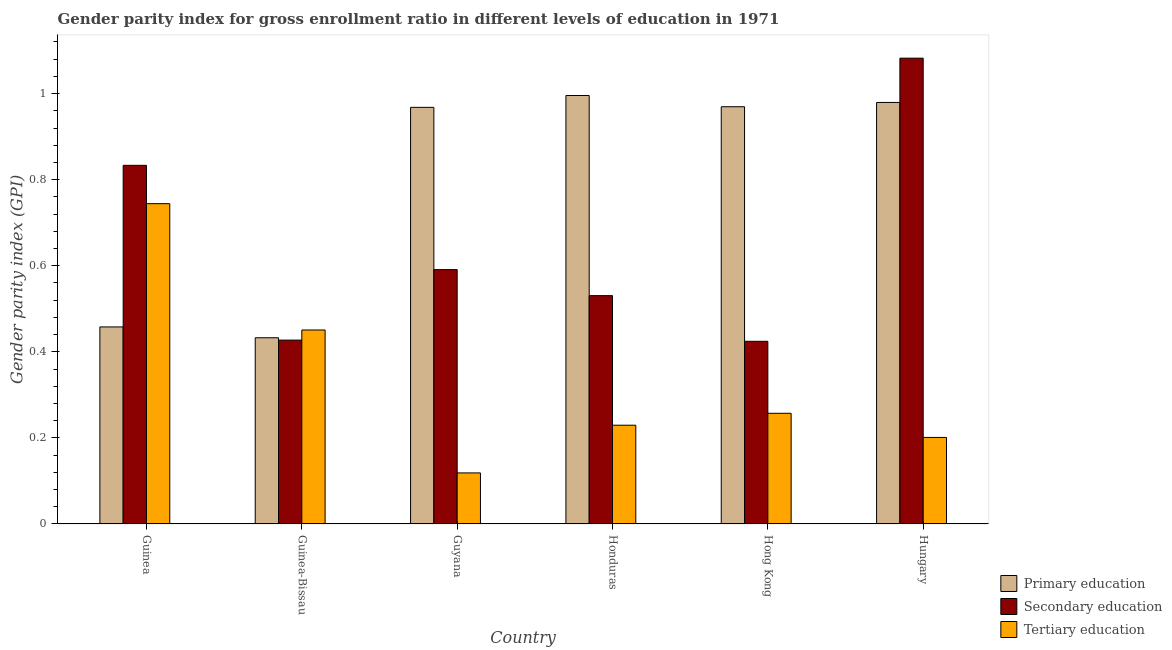Are the number of bars per tick equal to the number of legend labels?
Your answer should be very brief. Yes. How many bars are there on the 3rd tick from the left?
Your answer should be compact. 3. How many bars are there on the 5th tick from the right?
Make the answer very short. 3. What is the label of the 6th group of bars from the left?
Provide a succinct answer. Hungary. What is the gender parity index in secondary education in Guinea?
Your answer should be compact. 0.83. Across all countries, what is the maximum gender parity index in tertiary education?
Provide a short and direct response. 0.74. Across all countries, what is the minimum gender parity index in secondary education?
Your answer should be very brief. 0.42. In which country was the gender parity index in tertiary education maximum?
Offer a terse response. Guinea. In which country was the gender parity index in tertiary education minimum?
Make the answer very short. Guyana. What is the total gender parity index in primary education in the graph?
Ensure brevity in your answer.  4.8. What is the difference between the gender parity index in primary education in Guyana and that in Hungary?
Give a very brief answer. -0.01. What is the difference between the gender parity index in tertiary education in Guyana and the gender parity index in primary education in Honduras?
Keep it short and to the point. -0.88. What is the average gender parity index in tertiary education per country?
Your response must be concise. 0.33. What is the difference between the gender parity index in tertiary education and gender parity index in primary education in Hungary?
Offer a terse response. -0.78. In how many countries, is the gender parity index in secondary education greater than 0.9600000000000001 ?
Your answer should be very brief. 1. What is the ratio of the gender parity index in primary education in Honduras to that in Hong Kong?
Offer a very short reply. 1.03. Is the gender parity index in primary education in Guyana less than that in Hungary?
Offer a very short reply. Yes. What is the difference between the highest and the second highest gender parity index in tertiary education?
Provide a short and direct response. 0.29. What is the difference between the highest and the lowest gender parity index in primary education?
Offer a terse response. 0.56. In how many countries, is the gender parity index in primary education greater than the average gender parity index in primary education taken over all countries?
Your answer should be compact. 4. Is the sum of the gender parity index in tertiary education in Guyana and Hong Kong greater than the maximum gender parity index in primary education across all countries?
Give a very brief answer. No. What does the 2nd bar from the left in Hong Kong represents?
Your answer should be very brief. Secondary education. How many countries are there in the graph?
Your answer should be very brief. 6. Does the graph contain grids?
Ensure brevity in your answer.  No. Where does the legend appear in the graph?
Make the answer very short. Bottom right. What is the title of the graph?
Offer a terse response. Gender parity index for gross enrollment ratio in different levels of education in 1971. Does "Maunufacturing" appear as one of the legend labels in the graph?
Offer a terse response. No. What is the label or title of the X-axis?
Your answer should be very brief. Country. What is the label or title of the Y-axis?
Keep it short and to the point. Gender parity index (GPI). What is the Gender parity index (GPI) in Primary education in Guinea?
Make the answer very short. 0.46. What is the Gender parity index (GPI) of Tertiary education in Guinea?
Give a very brief answer. 0.74. What is the Gender parity index (GPI) of Primary education in Guinea-Bissau?
Your answer should be very brief. 0.43. What is the Gender parity index (GPI) of Secondary education in Guinea-Bissau?
Keep it short and to the point. 0.43. What is the Gender parity index (GPI) of Tertiary education in Guinea-Bissau?
Offer a terse response. 0.45. What is the Gender parity index (GPI) of Primary education in Guyana?
Offer a terse response. 0.97. What is the Gender parity index (GPI) of Secondary education in Guyana?
Keep it short and to the point. 0.59. What is the Gender parity index (GPI) of Tertiary education in Guyana?
Give a very brief answer. 0.12. What is the Gender parity index (GPI) of Primary education in Honduras?
Your response must be concise. 1. What is the Gender parity index (GPI) of Secondary education in Honduras?
Provide a succinct answer. 0.53. What is the Gender parity index (GPI) of Tertiary education in Honduras?
Offer a very short reply. 0.23. What is the Gender parity index (GPI) of Primary education in Hong Kong?
Your answer should be very brief. 0.97. What is the Gender parity index (GPI) of Secondary education in Hong Kong?
Your answer should be very brief. 0.42. What is the Gender parity index (GPI) of Tertiary education in Hong Kong?
Provide a succinct answer. 0.26. What is the Gender parity index (GPI) of Primary education in Hungary?
Your response must be concise. 0.98. What is the Gender parity index (GPI) of Secondary education in Hungary?
Keep it short and to the point. 1.08. What is the Gender parity index (GPI) in Tertiary education in Hungary?
Your response must be concise. 0.2. Across all countries, what is the maximum Gender parity index (GPI) in Primary education?
Your answer should be very brief. 1. Across all countries, what is the maximum Gender parity index (GPI) in Secondary education?
Your answer should be compact. 1.08. Across all countries, what is the maximum Gender parity index (GPI) of Tertiary education?
Make the answer very short. 0.74. Across all countries, what is the minimum Gender parity index (GPI) in Primary education?
Offer a very short reply. 0.43. Across all countries, what is the minimum Gender parity index (GPI) in Secondary education?
Provide a short and direct response. 0.42. Across all countries, what is the minimum Gender parity index (GPI) of Tertiary education?
Keep it short and to the point. 0.12. What is the total Gender parity index (GPI) of Primary education in the graph?
Keep it short and to the point. 4.8. What is the total Gender parity index (GPI) in Secondary education in the graph?
Your answer should be compact. 3.89. What is the total Gender parity index (GPI) in Tertiary education in the graph?
Your answer should be compact. 2. What is the difference between the Gender parity index (GPI) of Primary education in Guinea and that in Guinea-Bissau?
Offer a terse response. 0.03. What is the difference between the Gender parity index (GPI) in Secondary education in Guinea and that in Guinea-Bissau?
Your answer should be very brief. 0.41. What is the difference between the Gender parity index (GPI) of Tertiary education in Guinea and that in Guinea-Bissau?
Make the answer very short. 0.29. What is the difference between the Gender parity index (GPI) of Primary education in Guinea and that in Guyana?
Provide a succinct answer. -0.51. What is the difference between the Gender parity index (GPI) in Secondary education in Guinea and that in Guyana?
Give a very brief answer. 0.24. What is the difference between the Gender parity index (GPI) of Tertiary education in Guinea and that in Guyana?
Your answer should be very brief. 0.63. What is the difference between the Gender parity index (GPI) in Primary education in Guinea and that in Honduras?
Offer a very short reply. -0.54. What is the difference between the Gender parity index (GPI) in Secondary education in Guinea and that in Honduras?
Your answer should be compact. 0.3. What is the difference between the Gender parity index (GPI) of Tertiary education in Guinea and that in Honduras?
Ensure brevity in your answer.  0.51. What is the difference between the Gender parity index (GPI) of Primary education in Guinea and that in Hong Kong?
Give a very brief answer. -0.51. What is the difference between the Gender parity index (GPI) in Secondary education in Guinea and that in Hong Kong?
Your answer should be very brief. 0.41. What is the difference between the Gender parity index (GPI) of Tertiary education in Guinea and that in Hong Kong?
Your answer should be compact. 0.49. What is the difference between the Gender parity index (GPI) in Primary education in Guinea and that in Hungary?
Keep it short and to the point. -0.52. What is the difference between the Gender parity index (GPI) of Secondary education in Guinea and that in Hungary?
Your answer should be very brief. -0.25. What is the difference between the Gender parity index (GPI) of Tertiary education in Guinea and that in Hungary?
Offer a terse response. 0.54. What is the difference between the Gender parity index (GPI) in Primary education in Guinea-Bissau and that in Guyana?
Keep it short and to the point. -0.54. What is the difference between the Gender parity index (GPI) of Secondary education in Guinea-Bissau and that in Guyana?
Ensure brevity in your answer.  -0.16. What is the difference between the Gender parity index (GPI) in Tertiary education in Guinea-Bissau and that in Guyana?
Give a very brief answer. 0.33. What is the difference between the Gender parity index (GPI) of Primary education in Guinea-Bissau and that in Honduras?
Provide a succinct answer. -0.56. What is the difference between the Gender parity index (GPI) of Secondary education in Guinea-Bissau and that in Honduras?
Your answer should be very brief. -0.1. What is the difference between the Gender parity index (GPI) in Tertiary education in Guinea-Bissau and that in Honduras?
Your response must be concise. 0.22. What is the difference between the Gender parity index (GPI) of Primary education in Guinea-Bissau and that in Hong Kong?
Ensure brevity in your answer.  -0.54. What is the difference between the Gender parity index (GPI) of Secondary education in Guinea-Bissau and that in Hong Kong?
Offer a very short reply. 0. What is the difference between the Gender parity index (GPI) of Tertiary education in Guinea-Bissau and that in Hong Kong?
Give a very brief answer. 0.19. What is the difference between the Gender parity index (GPI) in Primary education in Guinea-Bissau and that in Hungary?
Offer a very short reply. -0.55. What is the difference between the Gender parity index (GPI) in Secondary education in Guinea-Bissau and that in Hungary?
Offer a terse response. -0.66. What is the difference between the Gender parity index (GPI) of Tertiary education in Guinea-Bissau and that in Hungary?
Provide a short and direct response. 0.25. What is the difference between the Gender parity index (GPI) of Primary education in Guyana and that in Honduras?
Give a very brief answer. -0.03. What is the difference between the Gender parity index (GPI) in Secondary education in Guyana and that in Honduras?
Your answer should be very brief. 0.06. What is the difference between the Gender parity index (GPI) of Tertiary education in Guyana and that in Honduras?
Make the answer very short. -0.11. What is the difference between the Gender parity index (GPI) of Primary education in Guyana and that in Hong Kong?
Ensure brevity in your answer.  -0. What is the difference between the Gender parity index (GPI) in Secondary education in Guyana and that in Hong Kong?
Ensure brevity in your answer.  0.17. What is the difference between the Gender parity index (GPI) in Tertiary education in Guyana and that in Hong Kong?
Offer a terse response. -0.14. What is the difference between the Gender parity index (GPI) in Primary education in Guyana and that in Hungary?
Your answer should be compact. -0.01. What is the difference between the Gender parity index (GPI) of Secondary education in Guyana and that in Hungary?
Offer a terse response. -0.49. What is the difference between the Gender parity index (GPI) of Tertiary education in Guyana and that in Hungary?
Keep it short and to the point. -0.08. What is the difference between the Gender parity index (GPI) in Primary education in Honduras and that in Hong Kong?
Offer a terse response. 0.03. What is the difference between the Gender parity index (GPI) of Secondary education in Honduras and that in Hong Kong?
Keep it short and to the point. 0.11. What is the difference between the Gender parity index (GPI) of Tertiary education in Honduras and that in Hong Kong?
Give a very brief answer. -0.03. What is the difference between the Gender parity index (GPI) of Primary education in Honduras and that in Hungary?
Your answer should be very brief. 0.02. What is the difference between the Gender parity index (GPI) of Secondary education in Honduras and that in Hungary?
Ensure brevity in your answer.  -0.55. What is the difference between the Gender parity index (GPI) in Tertiary education in Honduras and that in Hungary?
Provide a short and direct response. 0.03. What is the difference between the Gender parity index (GPI) in Primary education in Hong Kong and that in Hungary?
Provide a short and direct response. -0.01. What is the difference between the Gender parity index (GPI) of Secondary education in Hong Kong and that in Hungary?
Provide a succinct answer. -0.66. What is the difference between the Gender parity index (GPI) of Tertiary education in Hong Kong and that in Hungary?
Provide a short and direct response. 0.06. What is the difference between the Gender parity index (GPI) in Primary education in Guinea and the Gender parity index (GPI) in Secondary education in Guinea-Bissau?
Keep it short and to the point. 0.03. What is the difference between the Gender parity index (GPI) in Primary education in Guinea and the Gender parity index (GPI) in Tertiary education in Guinea-Bissau?
Provide a short and direct response. 0.01. What is the difference between the Gender parity index (GPI) in Secondary education in Guinea and the Gender parity index (GPI) in Tertiary education in Guinea-Bissau?
Your answer should be very brief. 0.38. What is the difference between the Gender parity index (GPI) in Primary education in Guinea and the Gender parity index (GPI) in Secondary education in Guyana?
Offer a very short reply. -0.13. What is the difference between the Gender parity index (GPI) of Primary education in Guinea and the Gender parity index (GPI) of Tertiary education in Guyana?
Give a very brief answer. 0.34. What is the difference between the Gender parity index (GPI) of Secondary education in Guinea and the Gender parity index (GPI) of Tertiary education in Guyana?
Your answer should be very brief. 0.71. What is the difference between the Gender parity index (GPI) in Primary education in Guinea and the Gender parity index (GPI) in Secondary education in Honduras?
Ensure brevity in your answer.  -0.07. What is the difference between the Gender parity index (GPI) of Primary education in Guinea and the Gender parity index (GPI) of Tertiary education in Honduras?
Your response must be concise. 0.23. What is the difference between the Gender parity index (GPI) of Secondary education in Guinea and the Gender parity index (GPI) of Tertiary education in Honduras?
Your answer should be compact. 0.6. What is the difference between the Gender parity index (GPI) of Primary education in Guinea and the Gender parity index (GPI) of Secondary education in Hong Kong?
Your answer should be very brief. 0.03. What is the difference between the Gender parity index (GPI) in Primary education in Guinea and the Gender parity index (GPI) in Tertiary education in Hong Kong?
Keep it short and to the point. 0.2. What is the difference between the Gender parity index (GPI) in Secondary education in Guinea and the Gender parity index (GPI) in Tertiary education in Hong Kong?
Offer a very short reply. 0.58. What is the difference between the Gender parity index (GPI) of Primary education in Guinea and the Gender parity index (GPI) of Secondary education in Hungary?
Offer a very short reply. -0.62. What is the difference between the Gender parity index (GPI) of Primary education in Guinea and the Gender parity index (GPI) of Tertiary education in Hungary?
Provide a succinct answer. 0.26. What is the difference between the Gender parity index (GPI) in Secondary education in Guinea and the Gender parity index (GPI) in Tertiary education in Hungary?
Give a very brief answer. 0.63. What is the difference between the Gender parity index (GPI) of Primary education in Guinea-Bissau and the Gender parity index (GPI) of Secondary education in Guyana?
Make the answer very short. -0.16. What is the difference between the Gender parity index (GPI) of Primary education in Guinea-Bissau and the Gender parity index (GPI) of Tertiary education in Guyana?
Keep it short and to the point. 0.31. What is the difference between the Gender parity index (GPI) in Secondary education in Guinea-Bissau and the Gender parity index (GPI) in Tertiary education in Guyana?
Provide a succinct answer. 0.31. What is the difference between the Gender parity index (GPI) in Primary education in Guinea-Bissau and the Gender parity index (GPI) in Secondary education in Honduras?
Provide a succinct answer. -0.1. What is the difference between the Gender parity index (GPI) in Primary education in Guinea-Bissau and the Gender parity index (GPI) in Tertiary education in Honduras?
Keep it short and to the point. 0.2. What is the difference between the Gender parity index (GPI) in Secondary education in Guinea-Bissau and the Gender parity index (GPI) in Tertiary education in Honduras?
Your response must be concise. 0.2. What is the difference between the Gender parity index (GPI) of Primary education in Guinea-Bissau and the Gender parity index (GPI) of Secondary education in Hong Kong?
Make the answer very short. 0.01. What is the difference between the Gender parity index (GPI) in Primary education in Guinea-Bissau and the Gender parity index (GPI) in Tertiary education in Hong Kong?
Ensure brevity in your answer.  0.18. What is the difference between the Gender parity index (GPI) in Secondary education in Guinea-Bissau and the Gender parity index (GPI) in Tertiary education in Hong Kong?
Your answer should be very brief. 0.17. What is the difference between the Gender parity index (GPI) of Primary education in Guinea-Bissau and the Gender parity index (GPI) of Secondary education in Hungary?
Offer a terse response. -0.65. What is the difference between the Gender parity index (GPI) in Primary education in Guinea-Bissau and the Gender parity index (GPI) in Tertiary education in Hungary?
Provide a short and direct response. 0.23. What is the difference between the Gender parity index (GPI) of Secondary education in Guinea-Bissau and the Gender parity index (GPI) of Tertiary education in Hungary?
Keep it short and to the point. 0.23. What is the difference between the Gender parity index (GPI) of Primary education in Guyana and the Gender parity index (GPI) of Secondary education in Honduras?
Make the answer very short. 0.44. What is the difference between the Gender parity index (GPI) of Primary education in Guyana and the Gender parity index (GPI) of Tertiary education in Honduras?
Offer a very short reply. 0.74. What is the difference between the Gender parity index (GPI) in Secondary education in Guyana and the Gender parity index (GPI) in Tertiary education in Honduras?
Your answer should be compact. 0.36. What is the difference between the Gender parity index (GPI) of Primary education in Guyana and the Gender parity index (GPI) of Secondary education in Hong Kong?
Your response must be concise. 0.54. What is the difference between the Gender parity index (GPI) in Primary education in Guyana and the Gender parity index (GPI) in Tertiary education in Hong Kong?
Offer a terse response. 0.71. What is the difference between the Gender parity index (GPI) in Secondary education in Guyana and the Gender parity index (GPI) in Tertiary education in Hong Kong?
Your response must be concise. 0.33. What is the difference between the Gender parity index (GPI) in Primary education in Guyana and the Gender parity index (GPI) in Secondary education in Hungary?
Your answer should be compact. -0.11. What is the difference between the Gender parity index (GPI) of Primary education in Guyana and the Gender parity index (GPI) of Tertiary education in Hungary?
Your answer should be very brief. 0.77. What is the difference between the Gender parity index (GPI) of Secondary education in Guyana and the Gender parity index (GPI) of Tertiary education in Hungary?
Your answer should be very brief. 0.39. What is the difference between the Gender parity index (GPI) in Primary education in Honduras and the Gender parity index (GPI) in Secondary education in Hong Kong?
Offer a terse response. 0.57. What is the difference between the Gender parity index (GPI) in Primary education in Honduras and the Gender parity index (GPI) in Tertiary education in Hong Kong?
Offer a terse response. 0.74. What is the difference between the Gender parity index (GPI) of Secondary education in Honduras and the Gender parity index (GPI) of Tertiary education in Hong Kong?
Offer a very short reply. 0.27. What is the difference between the Gender parity index (GPI) of Primary education in Honduras and the Gender parity index (GPI) of Secondary education in Hungary?
Offer a very short reply. -0.09. What is the difference between the Gender parity index (GPI) of Primary education in Honduras and the Gender parity index (GPI) of Tertiary education in Hungary?
Make the answer very short. 0.79. What is the difference between the Gender parity index (GPI) of Secondary education in Honduras and the Gender parity index (GPI) of Tertiary education in Hungary?
Your answer should be very brief. 0.33. What is the difference between the Gender parity index (GPI) of Primary education in Hong Kong and the Gender parity index (GPI) of Secondary education in Hungary?
Keep it short and to the point. -0.11. What is the difference between the Gender parity index (GPI) in Primary education in Hong Kong and the Gender parity index (GPI) in Tertiary education in Hungary?
Your answer should be compact. 0.77. What is the difference between the Gender parity index (GPI) in Secondary education in Hong Kong and the Gender parity index (GPI) in Tertiary education in Hungary?
Keep it short and to the point. 0.22. What is the average Gender parity index (GPI) in Primary education per country?
Your answer should be very brief. 0.8. What is the average Gender parity index (GPI) in Secondary education per country?
Offer a very short reply. 0.65. What is the average Gender parity index (GPI) in Tertiary education per country?
Make the answer very short. 0.33. What is the difference between the Gender parity index (GPI) in Primary education and Gender parity index (GPI) in Secondary education in Guinea?
Your response must be concise. -0.38. What is the difference between the Gender parity index (GPI) in Primary education and Gender parity index (GPI) in Tertiary education in Guinea?
Offer a terse response. -0.29. What is the difference between the Gender parity index (GPI) in Secondary education and Gender parity index (GPI) in Tertiary education in Guinea?
Offer a terse response. 0.09. What is the difference between the Gender parity index (GPI) of Primary education and Gender parity index (GPI) of Secondary education in Guinea-Bissau?
Provide a short and direct response. 0.01. What is the difference between the Gender parity index (GPI) of Primary education and Gender parity index (GPI) of Tertiary education in Guinea-Bissau?
Provide a short and direct response. -0.02. What is the difference between the Gender parity index (GPI) of Secondary education and Gender parity index (GPI) of Tertiary education in Guinea-Bissau?
Offer a very short reply. -0.02. What is the difference between the Gender parity index (GPI) of Primary education and Gender parity index (GPI) of Secondary education in Guyana?
Your answer should be compact. 0.38. What is the difference between the Gender parity index (GPI) in Primary education and Gender parity index (GPI) in Tertiary education in Guyana?
Ensure brevity in your answer.  0.85. What is the difference between the Gender parity index (GPI) of Secondary education and Gender parity index (GPI) of Tertiary education in Guyana?
Ensure brevity in your answer.  0.47. What is the difference between the Gender parity index (GPI) of Primary education and Gender parity index (GPI) of Secondary education in Honduras?
Your answer should be very brief. 0.47. What is the difference between the Gender parity index (GPI) in Primary education and Gender parity index (GPI) in Tertiary education in Honduras?
Your answer should be very brief. 0.77. What is the difference between the Gender parity index (GPI) in Secondary education and Gender parity index (GPI) in Tertiary education in Honduras?
Give a very brief answer. 0.3. What is the difference between the Gender parity index (GPI) in Primary education and Gender parity index (GPI) in Secondary education in Hong Kong?
Provide a short and direct response. 0.55. What is the difference between the Gender parity index (GPI) of Primary education and Gender parity index (GPI) of Tertiary education in Hong Kong?
Provide a short and direct response. 0.71. What is the difference between the Gender parity index (GPI) of Secondary education and Gender parity index (GPI) of Tertiary education in Hong Kong?
Keep it short and to the point. 0.17. What is the difference between the Gender parity index (GPI) in Primary education and Gender parity index (GPI) in Secondary education in Hungary?
Make the answer very short. -0.1. What is the difference between the Gender parity index (GPI) in Primary education and Gender parity index (GPI) in Tertiary education in Hungary?
Your answer should be very brief. 0.78. What is the difference between the Gender parity index (GPI) of Secondary education and Gender parity index (GPI) of Tertiary education in Hungary?
Offer a very short reply. 0.88. What is the ratio of the Gender parity index (GPI) in Primary education in Guinea to that in Guinea-Bissau?
Make the answer very short. 1.06. What is the ratio of the Gender parity index (GPI) of Secondary education in Guinea to that in Guinea-Bissau?
Your answer should be very brief. 1.95. What is the ratio of the Gender parity index (GPI) in Tertiary education in Guinea to that in Guinea-Bissau?
Give a very brief answer. 1.65. What is the ratio of the Gender parity index (GPI) in Primary education in Guinea to that in Guyana?
Ensure brevity in your answer.  0.47. What is the ratio of the Gender parity index (GPI) of Secondary education in Guinea to that in Guyana?
Keep it short and to the point. 1.41. What is the ratio of the Gender parity index (GPI) of Tertiary education in Guinea to that in Guyana?
Your response must be concise. 6.27. What is the ratio of the Gender parity index (GPI) in Primary education in Guinea to that in Honduras?
Your answer should be compact. 0.46. What is the ratio of the Gender parity index (GPI) of Secondary education in Guinea to that in Honduras?
Offer a very short reply. 1.57. What is the ratio of the Gender parity index (GPI) in Tertiary education in Guinea to that in Honduras?
Make the answer very short. 3.24. What is the ratio of the Gender parity index (GPI) in Primary education in Guinea to that in Hong Kong?
Your answer should be very brief. 0.47. What is the ratio of the Gender parity index (GPI) of Secondary education in Guinea to that in Hong Kong?
Your answer should be very brief. 1.96. What is the ratio of the Gender parity index (GPI) of Tertiary education in Guinea to that in Hong Kong?
Offer a very short reply. 2.89. What is the ratio of the Gender parity index (GPI) in Primary education in Guinea to that in Hungary?
Provide a succinct answer. 0.47. What is the ratio of the Gender parity index (GPI) in Secondary education in Guinea to that in Hungary?
Provide a short and direct response. 0.77. What is the ratio of the Gender parity index (GPI) in Tertiary education in Guinea to that in Hungary?
Your answer should be compact. 3.7. What is the ratio of the Gender parity index (GPI) in Primary education in Guinea-Bissau to that in Guyana?
Provide a short and direct response. 0.45. What is the ratio of the Gender parity index (GPI) in Secondary education in Guinea-Bissau to that in Guyana?
Offer a very short reply. 0.72. What is the ratio of the Gender parity index (GPI) in Tertiary education in Guinea-Bissau to that in Guyana?
Make the answer very short. 3.8. What is the ratio of the Gender parity index (GPI) in Primary education in Guinea-Bissau to that in Honduras?
Keep it short and to the point. 0.43. What is the ratio of the Gender parity index (GPI) of Secondary education in Guinea-Bissau to that in Honduras?
Your answer should be compact. 0.81. What is the ratio of the Gender parity index (GPI) in Tertiary education in Guinea-Bissau to that in Honduras?
Make the answer very short. 1.96. What is the ratio of the Gender parity index (GPI) of Primary education in Guinea-Bissau to that in Hong Kong?
Offer a terse response. 0.45. What is the ratio of the Gender parity index (GPI) of Secondary education in Guinea-Bissau to that in Hong Kong?
Your answer should be very brief. 1.01. What is the ratio of the Gender parity index (GPI) in Tertiary education in Guinea-Bissau to that in Hong Kong?
Provide a succinct answer. 1.75. What is the ratio of the Gender parity index (GPI) in Primary education in Guinea-Bissau to that in Hungary?
Provide a succinct answer. 0.44. What is the ratio of the Gender parity index (GPI) of Secondary education in Guinea-Bissau to that in Hungary?
Your response must be concise. 0.39. What is the ratio of the Gender parity index (GPI) of Tertiary education in Guinea-Bissau to that in Hungary?
Offer a very short reply. 2.24. What is the ratio of the Gender parity index (GPI) of Primary education in Guyana to that in Honduras?
Keep it short and to the point. 0.97. What is the ratio of the Gender parity index (GPI) of Secondary education in Guyana to that in Honduras?
Keep it short and to the point. 1.11. What is the ratio of the Gender parity index (GPI) in Tertiary education in Guyana to that in Honduras?
Ensure brevity in your answer.  0.52. What is the ratio of the Gender parity index (GPI) in Primary education in Guyana to that in Hong Kong?
Offer a terse response. 1. What is the ratio of the Gender parity index (GPI) of Secondary education in Guyana to that in Hong Kong?
Provide a succinct answer. 1.39. What is the ratio of the Gender parity index (GPI) of Tertiary education in Guyana to that in Hong Kong?
Give a very brief answer. 0.46. What is the ratio of the Gender parity index (GPI) in Primary education in Guyana to that in Hungary?
Offer a terse response. 0.99. What is the ratio of the Gender parity index (GPI) of Secondary education in Guyana to that in Hungary?
Your response must be concise. 0.55. What is the ratio of the Gender parity index (GPI) in Tertiary education in Guyana to that in Hungary?
Your answer should be very brief. 0.59. What is the ratio of the Gender parity index (GPI) of Primary education in Honduras to that in Hong Kong?
Provide a short and direct response. 1.03. What is the ratio of the Gender parity index (GPI) in Tertiary education in Honduras to that in Hong Kong?
Offer a terse response. 0.89. What is the ratio of the Gender parity index (GPI) in Primary education in Honduras to that in Hungary?
Ensure brevity in your answer.  1.02. What is the ratio of the Gender parity index (GPI) of Secondary education in Honduras to that in Hungary?
Provide a short and direct response. 0.49. What is the ratio of the Gender parity index (GPI) in Tertiary education in Honduras to that in Hungary?
Your answer should be compact. 1.14. What is the ratio of the Gender parity index (GPI) of Secondary education in Hong Kong to that in Hungary?
Your answer should be compact. 0.39. What is the ratio of the Gender parity index (GPI) in Tertiary education in Hong Kong to that in Hungary?
Give a very brief answer. 1.28. What is the difference between the highest and the second highest Gender parity index (GPI) in Primary education?
Ensure brevity in your answer.  0.02. What is the difference between the highest and the second highest Gender parity index (GPI) in Secondary education?
Keep it short and to the point. 0.25. What is the difference between the highest and the second highest Gender parity index (GPI) of Tertiary education?
Your response must be concise. 0.29. What is the difference between the highest and the lowest Gender parity index (GPI) in Primary education?
Provide a short and direct response. 0.56. What is the difference between the highest and the lowest Gender parity index (GPI) of Secondary education?
Offer a very short reply. 0.66. What is the difference between the highest and the lowest Gender parity index (GPI) of Tertiary education?
Keep it short and to the point. 0.63. 